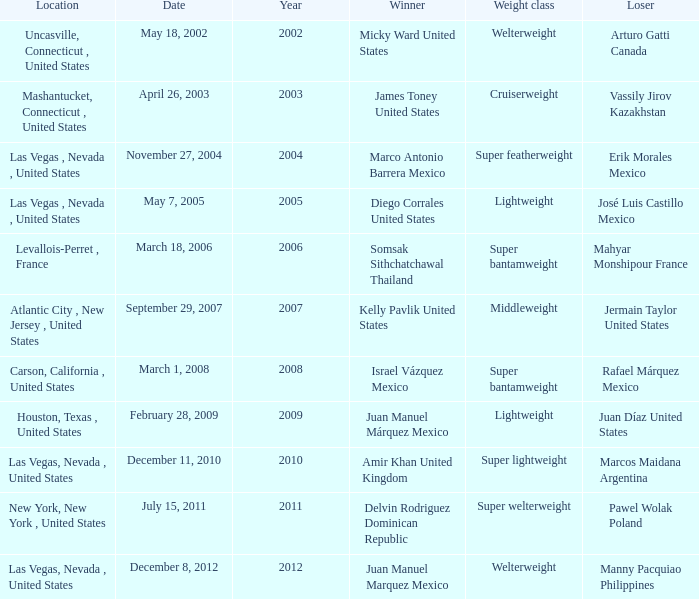How many years were lightweight class on february 28, 2009? 1.0. 